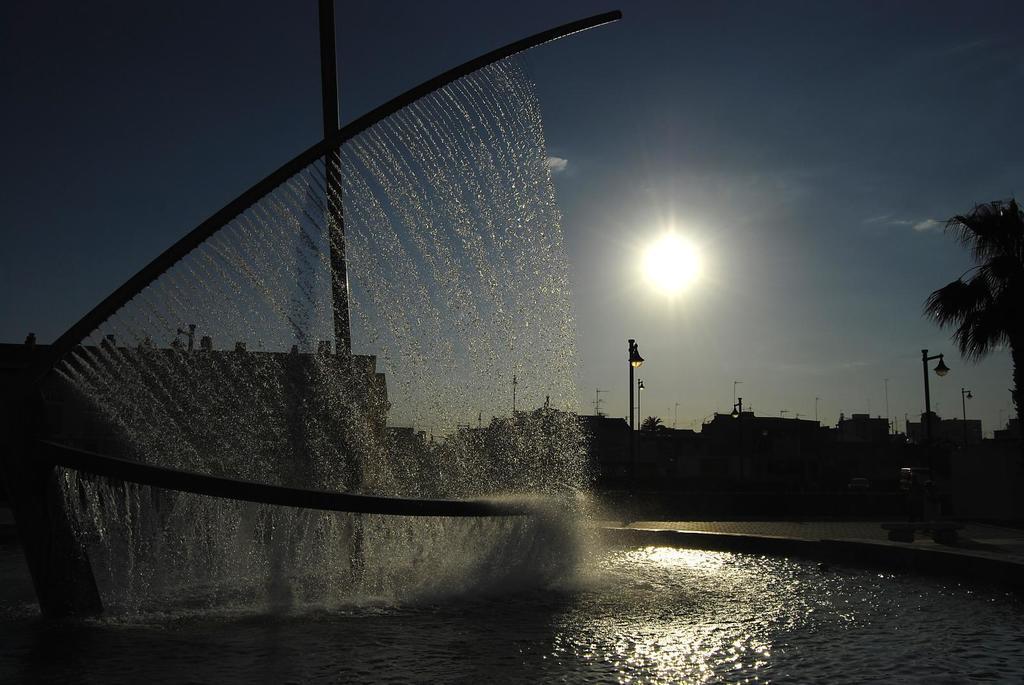Could you give a brief overview of what you see in this image? In this image we can see a fountain. We can see the water in the image. We can see the sun in the sky. There are few buildings in the image. There is a tree at the right side of the image. 